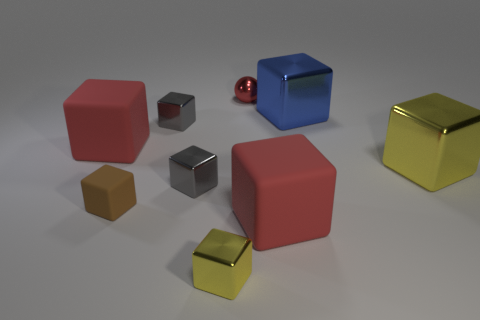Is the color of the tiny rubber thing the same as the large cube that is on the right side of the blue shiny object?
Your answer should be compact. No. What color is the large metal object that is behind the big thing that is to the left of the red block on the right side of the tiny matte block?
Provide a succinct answer. Blue. Are there any other large things of the same shape as the brown object?
Your response must be concise. Yes. There is a sphere that is the same size as the brown block; what is its color?
Give a very brief answer. Red. What is the yellow object that is in front of the brown matte thing made of?
Keep it short and to the point. Metal. Does the small thing behind the blue cube have the same shape as the yellow object left of the small red thing?
Your answer should be compact. No. Are there an equal number of brown objects that are on the left side of the tiny brown thing and large red things?
Provide a short and direct response. No. What number of tiny blue balls have the same material as the small yellow thing?
Give a very brief answer. 0. There is a sphere that is the same material as the tiny yellow cube; what color is it?
Make the answer very short. Red. Does the blue shiny block have the same size as the cube right of the blue object?
Your answer should be compact. Yes. 